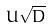<formula> <loc_0><loc_0><loc_500><loc_500>U \sqrt { D }</formula> 